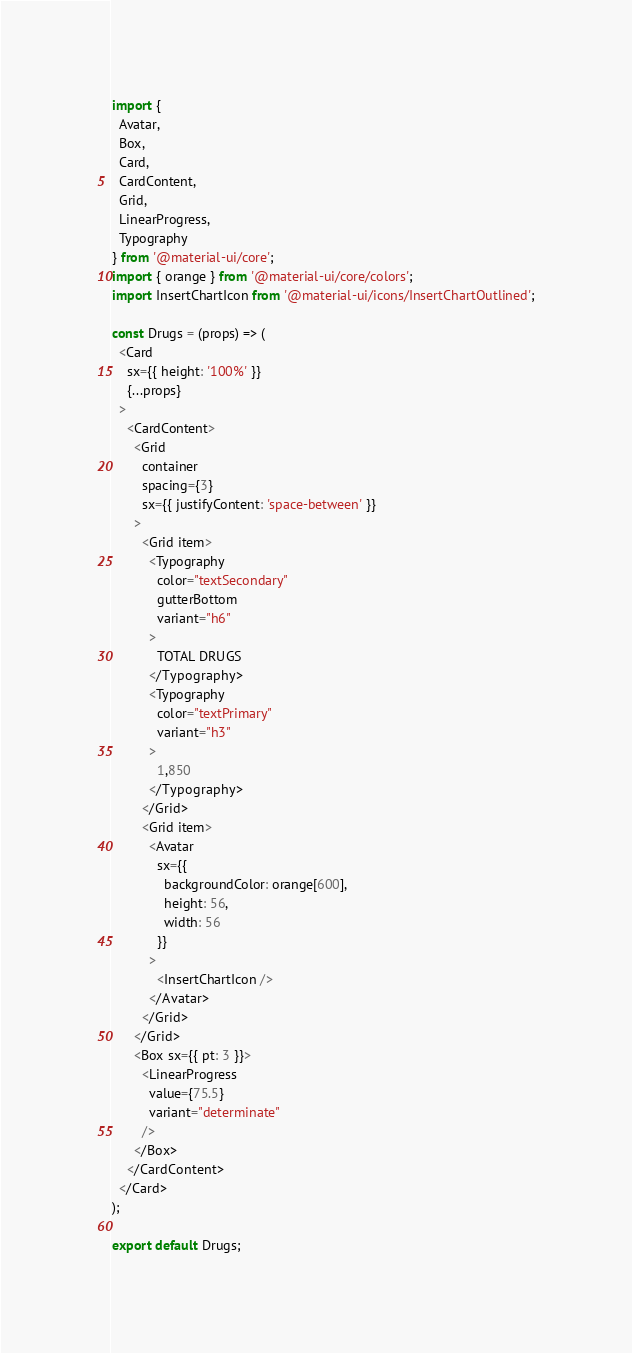Convert code to text. <code><loc_0><loc_0><loc_500><loc_500><_JavaScript_>import {
  Avatar,
  Box,
  Card,
  CardContent,
  Grid,
  LinearProgress,
  Typography
} from '@material-ui/core';
import { orange } from '@material-ui/core/colors';
import InsertChartIcon from '@material-ui/icons/InsertChartOutlined';

const Drugs = (props) => (
  <Card
    sx={{ height: '100%' }}
    {...props}
  >
    <CardContent>
      <Grid
        container
        spacing={3}
        sx={{ justifyContent: 'space-between' }}
      >
        <Grid item>
          <Typography
            color="textSecondary"
            gutterBottom
            variant="h6"
          >
            TOTAL DRUGS
          </Typography>
          <Typography
            color="textPrimary"
            variant="h3"
          >
            1,850
          </Typography>
        </Grid>
        <Grid item>
          <Avatar
            sx={{
              backgroundColor: orange[600],
              height: 56,
              width: 56
            }}
          >
            <InsertChartIcon />
          </Avatar>
        </Grid>
      </Grid>
      <Box sx={{ pt: 3 }}>
        <LinearProgress
          value={75.5}
          variant="determinate"
        />
      </Box>
    </CardContent>
  </Card>
);

export default Drugs;
</code> 